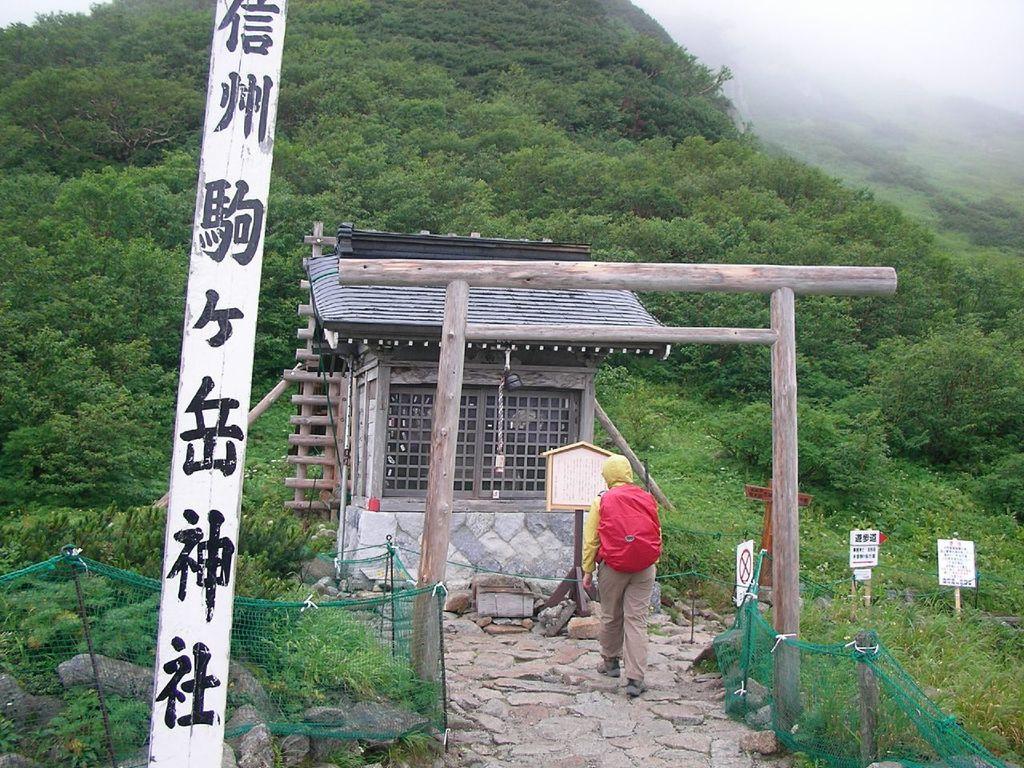In one or two sentences, can you explain what this image depicts? In the picture I can see a person carrying red color backpack is walking on the ground. Here I can see fence, boards, house, trees and fog in the background. 